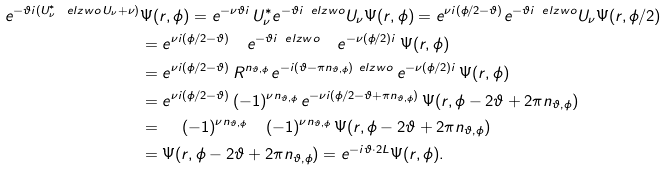<formula> <loc_0><loc_0><loc_500><loc_500>e ^ { - \vartheta i ( U _ { \nu } ^ { * } \, \ e l z w o \, U _ { \nu } + \nu ) } & \Psi ( r , \phi ) = e ^ { - \nu \vartheta i } \, U _ { \nu } ^ { * } e ^ { - \vartheta i \, \ e l z w o } U _ { \nu } \Psi ( r , \phi ) = e ^ { \nu i ( \phi / 2 - \vartheta ) } e ^ { - \vartheta i \, \ e l z w o } U _ { \nu } \Psi ( r , \phi / 2 ) \\ & = e ^ { \nu i ( \phi / 2 - \vartheta ) } \quad e ^ { - \vartheta i \, \ e l z w o } \quad e ^ { - \nu ( \phi / 2 ) i } \, \Psi ( r , \phi ) \\ & = e ^ { \nu i ( \phi / 2 - \vartheta ) } \, R ^ { n _ { \vartheta , \phi } } \, e ^ { - i ( \vartheta - \pi n _ { \vartheta , \phi } ) \ e l z w o } \, e ^ { - \nu ( \phi / 2 ) i } \, \Psi ( r , \phi ) \\ & = e ^ { \nu i ( \phi / 2 - \vartheta ) } \, ( - 1 ) ^ { \nu n _ { \vartheta , \phi } } \, e ^ { - \nu i ( \phi / 2 - \vartheta + \pi n _ { \vartheta , \phi } ) } \, \Psi ( r , \phi - 2 \vartheta + 2 \pi n _ { \vartheta , \phi } ) \\ & = \quad \, ( - 1 ) ^ { \nu n _ { \vartheta , \phi } } \quad \, ( - 1 ) ^ { \nu n _ { \vartheta , \phi } } \, \Psi ( r , \phi - 2 \vartheta + 2 \pi n _ { \vartheta , \phi } ) \\ & = \Psi ( r , \phi - 2 \vartheta + 2 \pi n _ { \vartheta , \phi } ) = e ^ { - i \vartheta \cdot 2 L } \Psi ( r , \phi ) .</formula> 